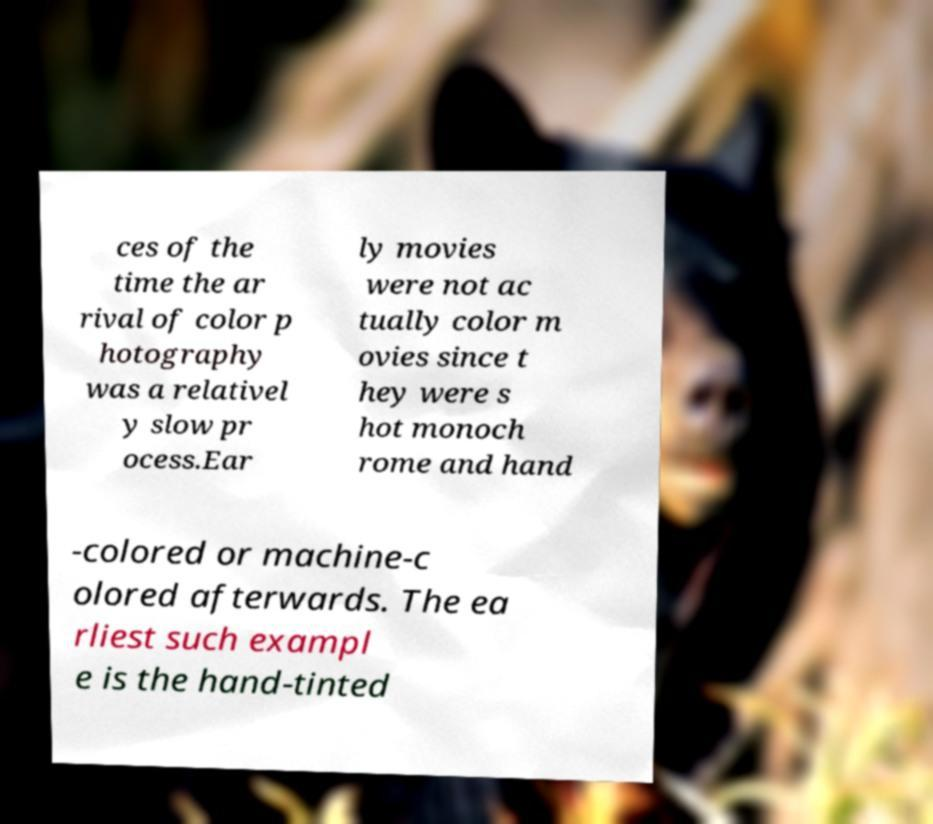Please read and relay the text visible in this image. What does it say? ces of the time the ar rival of color p hotography was a relativel y slow pr ocess.Ear ly movies were not ac tually color m ovies since t hey were s hot monoch rome and hand -colored or machine-c olored afterwards. The ea rliest such exampl e is the hand-tinted 